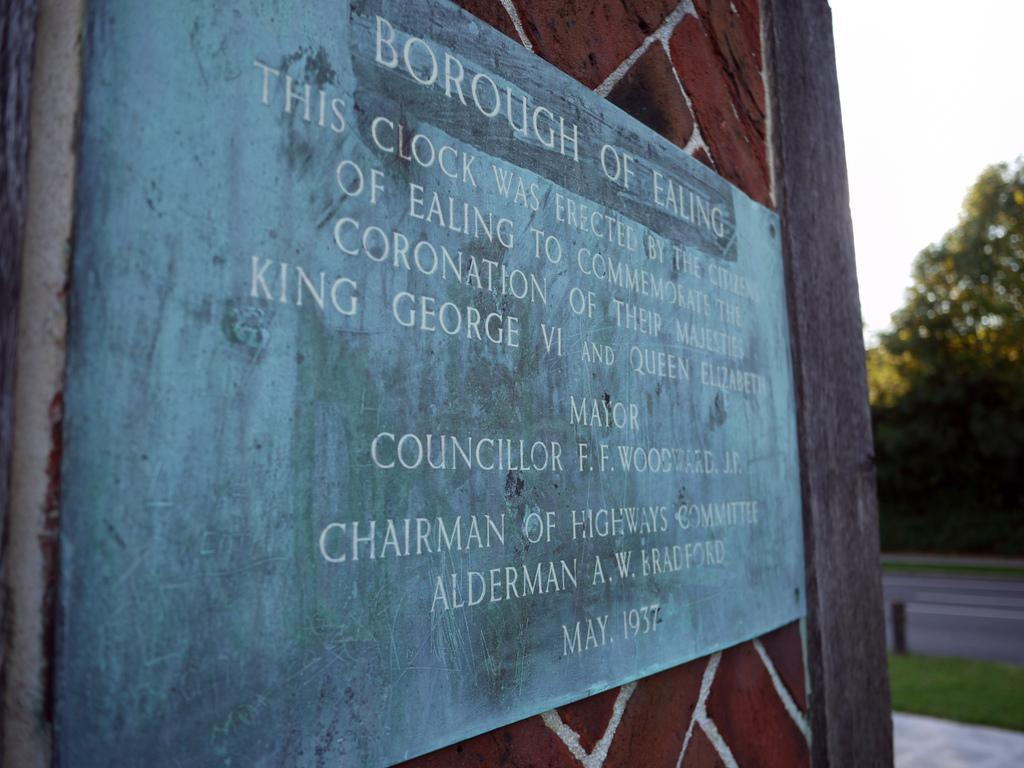Provide a one-sentence caption for the provided image. The sign for interested visitors tells of the reason for the erection of the clock at this location. 